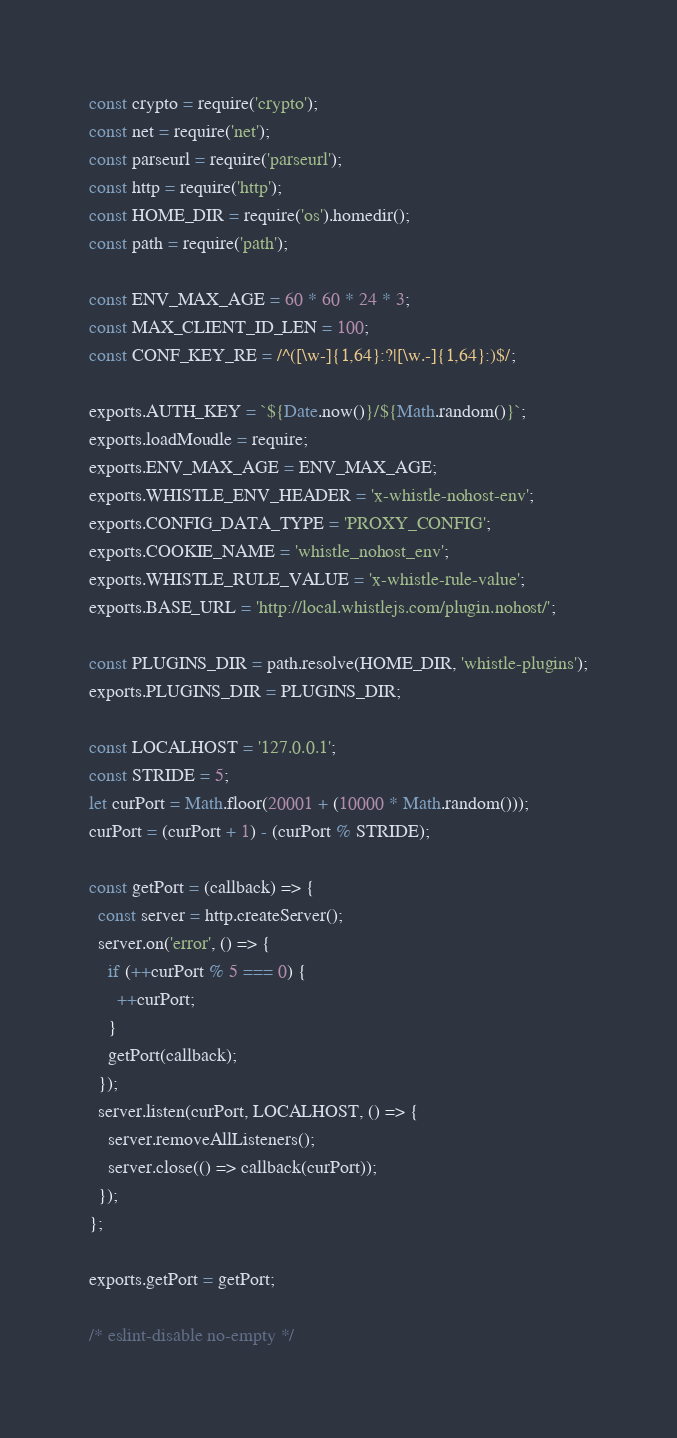<code> <loc_0><loc_0><loc_500><loc_500><_JavaScript_>const crypto = require('crypto');
const net = require('net');
const parseurl = require('parseurl');
const http = require('http');
const HOME_DIR = require('os').homedir();
const path = require('path');

const ENV_MAX_AGE = 60 * 60 * 24 * 3;
const MAX_CLIENT_ID_LEN = 100;
const CONF_KEY_RE = /^([\w-]{1,64}:?|[\w.-]{1,64}:)$/;

exports.AUTH_KEY = `${Date.now()}/${Math.random()}`;
exports.loadMoudle = require;
exports.ENV_MAX_AGE = ENV_MAX_AGE;
exports.WHISTLE_ENV_HEADER = 'x-whistle-nohost-env';
exports.CONFIG_DATA_TYPE = 'PROXY_CONFIG';
exports.COOKIE_NAME = 'whistle_nohost_env';
exports.WHISTLE_RULE_VALUE = 'x-whistle-rule-value';
exports.BASE_URL = 'http://local.whistlejs.com/plugin.nohost/';

const PLUGINS_DIR = path.resolve(HOME_DIR, 'whistle-plugins');
exports.PLUGINS_DIR = PLUGINS_DIR;

const LOCALHOST = '127.0.0.1';
const STRIDE = 5;
let curPort = Math.floor(20001 + (10000 * Math.random()));
curPort = (curPort + 1) - (curPort % STRIDE);

const getPort = (callback) => {
  const server = http.createServer();
  server.on('error', () => {
    if (++curPort % 5 === 0) {
      ++curPort;
    }
    getPort(callback);
  });
  server.listen(curPort, LOCALHOST, () => {
    server.removeAllListeners();
    server.close(() => callback(curPort));
  });
};

exports.getPort = getPort;

/* eslint-disable no-empty */</code> 